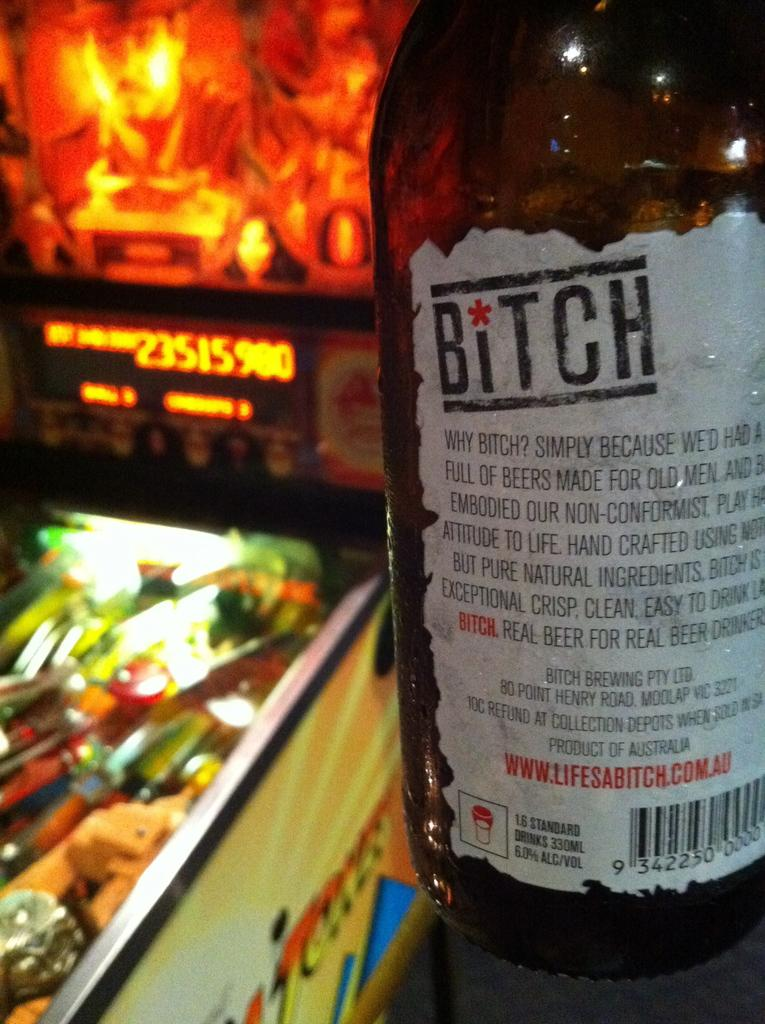<image>
Describe the image concisely. A brown botte of bitch brand beer in front of a pinball machine. 